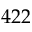<formula> <loc_0><loc_0><loc_500><loc_500>4 2 2</formula> 